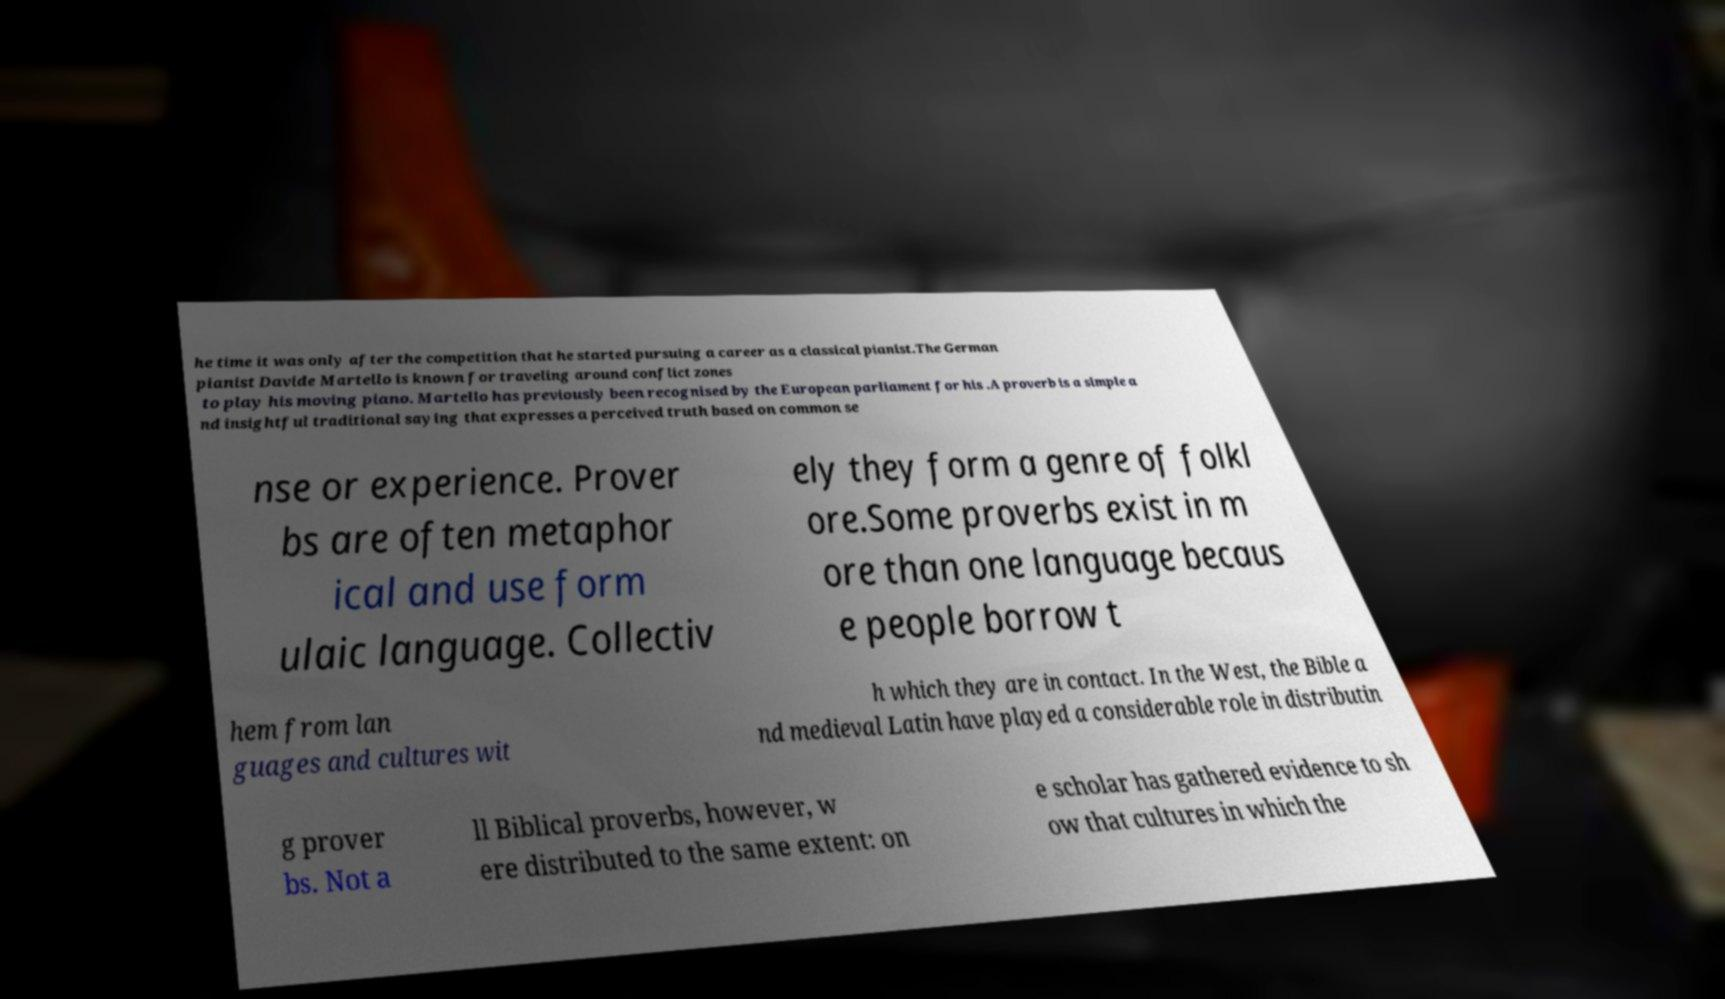Please read and relay the text visible in this image. What does it say? he time it was only after the competition that he started pursuing a career as a classical pianist.The German pianist Davide Martello is known for traveling around conflict zones to play his moving piano. Martello has previously been recognised by the European parliament for his .A proverb is a simple a nd insightful traditional saying that expresses a perceived truth based on common se nse or experience. Prover bs are often metaphor ical and use form ulaic language. Collectiv ely they form a genre of folkl ore.Some proverbs exist in m ore than one language becaus e people borrow t hem from lan guages and cultures wit h which they are in contact. In the West, the Bible a nd medieval Latin have played a considerable role in distributin g prover bs. Not a ll Biblical proverbs, however, w ere distributed to the same extent: on e scholar has gathered evidence to sh ow that cultures in which the 